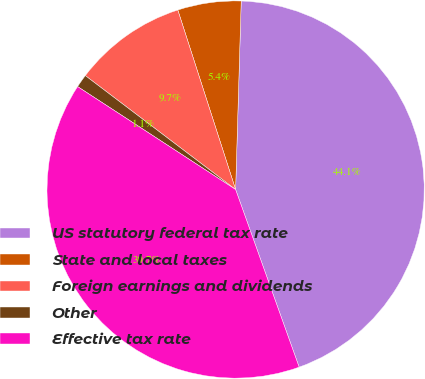Convert chart to OTSL. <chart><loc_0><loc_0><loc_500><loc_500><pie_chart><fcel>US statutory federal tax rate<fcel>State and local taxes<fcel>Foreign earnings and dividends<fcel>Other<fcel>Effective tax rate<nl><fcel>44.06%<fcel>5.43%<fcel>9.72%<fcel>1.13%<fcel>39.66%<nl></chart> 